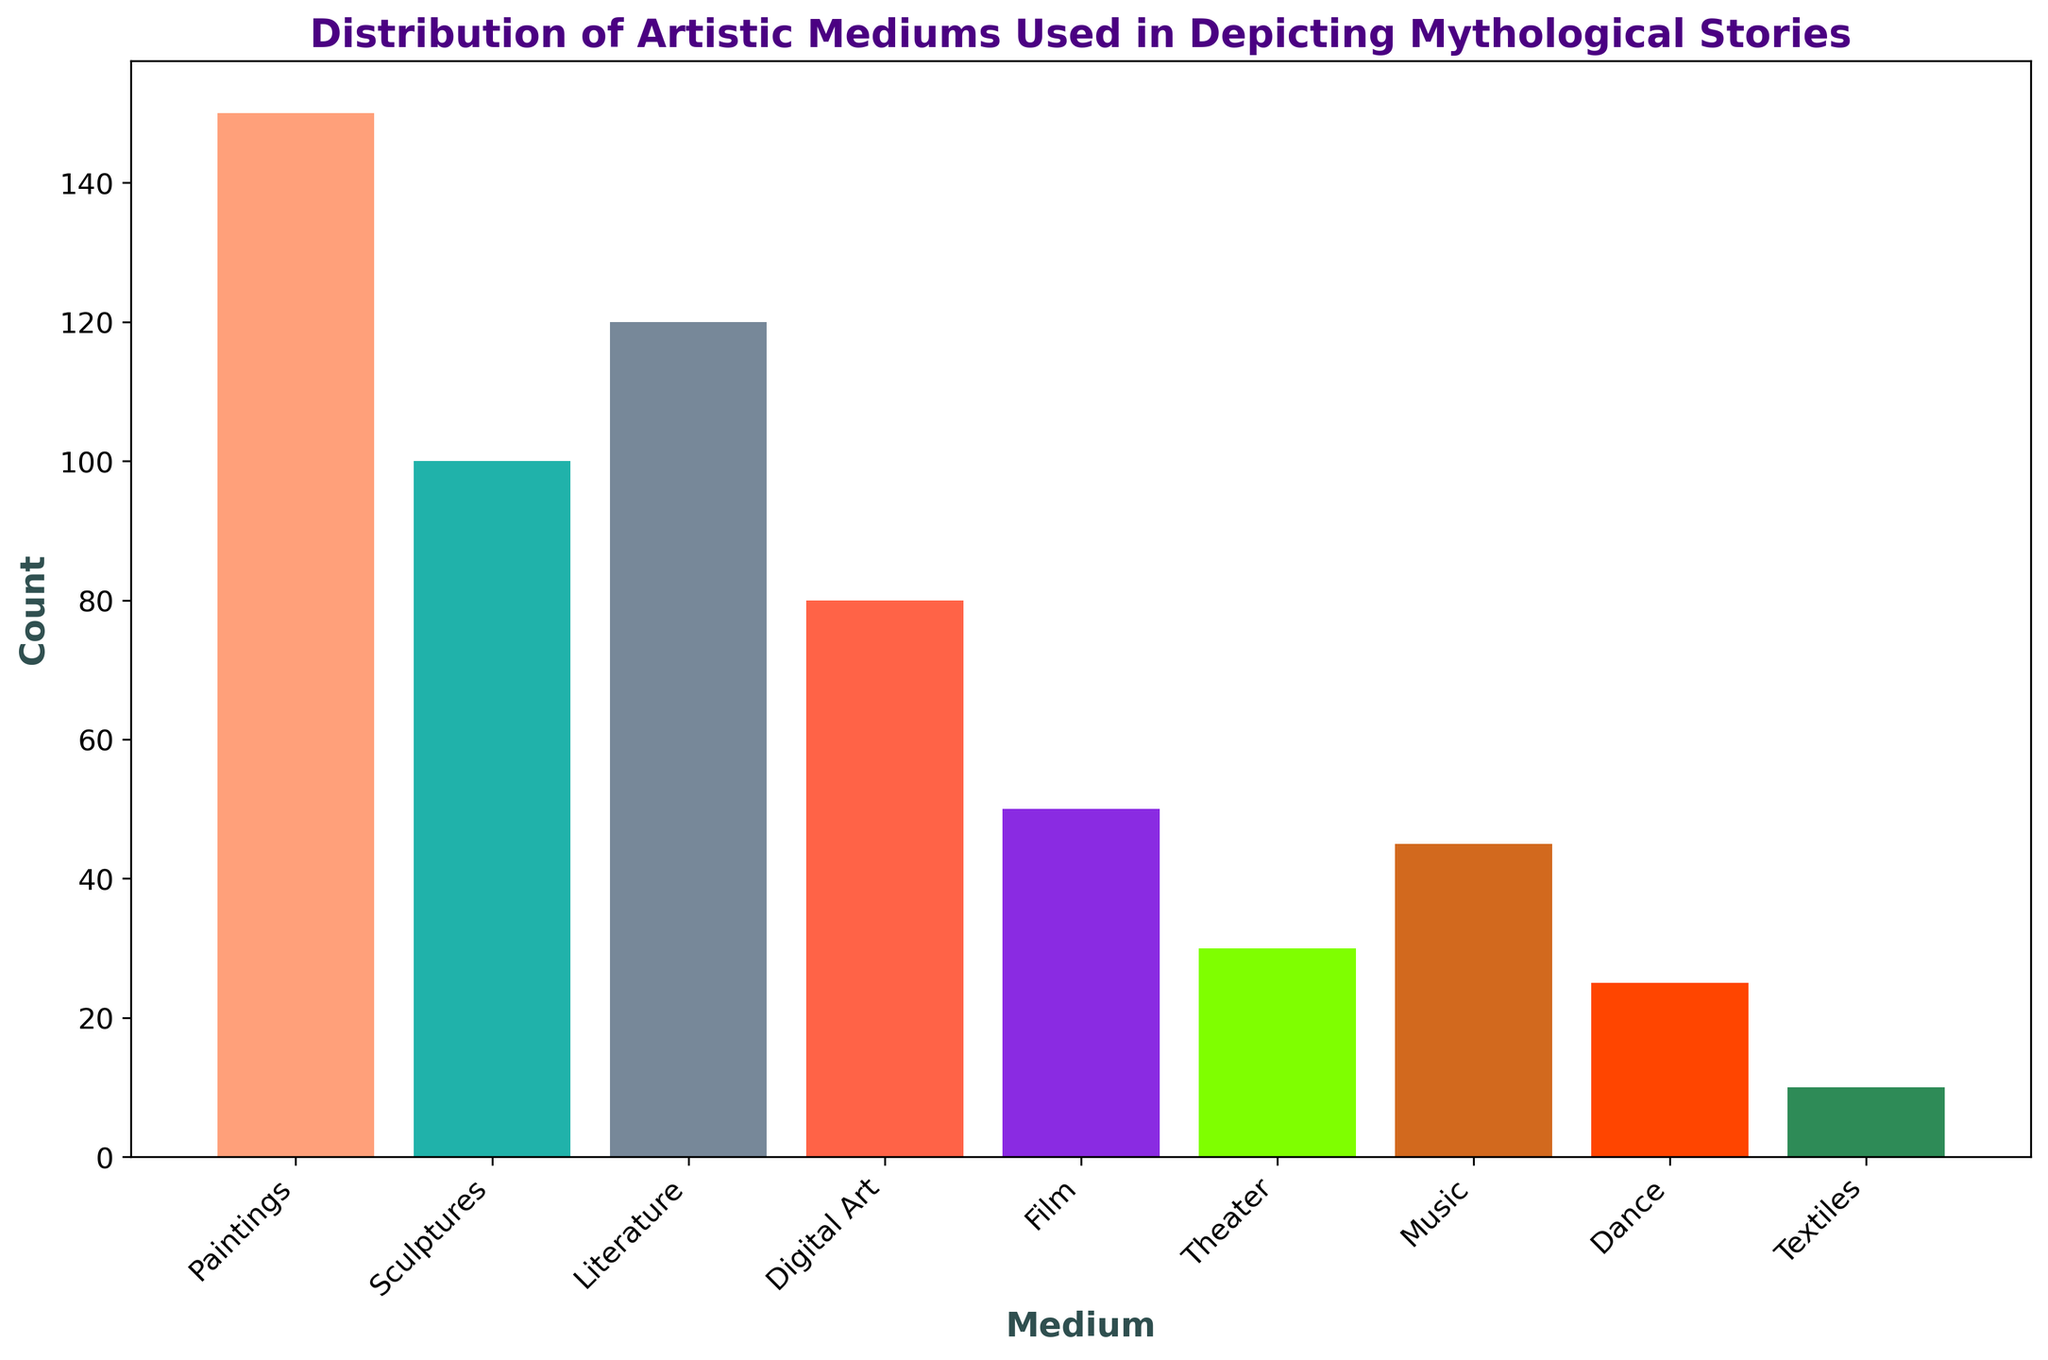What is the total count of all artistic mediums combined? To find the total count of all artistic mediums combined, sum the counts for each medium: 150 (Paintings) + 100 (Sculptures) + 120 (Literature) + 80 (Digital Art) + 50 (Film) + 30 (Theater) + 45 (Music) + 25 (Dance) + 10 (Textiles) = 610.
Answer: 610 Which artistic medium depicts the least number of mythological stories? By examining the height of the bars, the shortest bar represents the Textiles medium, which has a count of 10.
Answer: Textiles How many more stories are depicted in Paintings compared to Film? To find how many more stories are depicted in Paintings compared to Film, subtract the count of Film from the count of Paintings: 150 (Paintings) - 50 (Film) = 100.
Answer: 100 What percentage of the total does the Sculpture medium represent? First, calculate the total count of all mediums, which is 610. Then, to find the percentage for Sculptures, divide the count of Sculptures by the total count and multiply by 100: (100 / 610) * 100 ≈ 16.39%.
Answer: 16.39% Which mediums have counts greater than the average count of all mediums? First, calculate the total count (610) and divide by the number of mediums (9) to get the average: 610 / 9 ≈ 67.78. Mediums with counts greater than 67.78 are: Paintings (150), Sculptures (100), Literature (120), and Digital Art (80).
Answer: Paintings, Sculptures, Literature, Digital Art What is the combined count of Dance and Textiles mediums? Sum the counts for Dance and Textiles: 25 (Dance) + 10 (Textiles) = 35.
Answer: 35 Is the count of stories in Music more or less than in Theater? By comparing the heights of the bars, Music (45) has a higher count than Theater (30).
Answer: More What is the median count of the artistic mediums? To find the median, list the counts in ascending order: 10 (Textiles), 25 (Dance), 30 (Theater), 45 (Music), 50 (Film), 80 (Digital Art), 100 (Sculptures), 120 (Literature), 150 (Paintings). The median is the middle value: 50 (Film).
Answer: 50 In which color is the bar for Digital Art represented? By examining the colors of the bars, the bar for Digital Art is represented in a reddish-orange color.
Answer: Reddish-orange Which medium has the closest count to the average count? First, calculate the average count: total count (610) divided by the number of mediums (9) is approximately 67.78. The medium with the count closest to this average is Digital Art with a count of 80.
Answer: Digital Art 